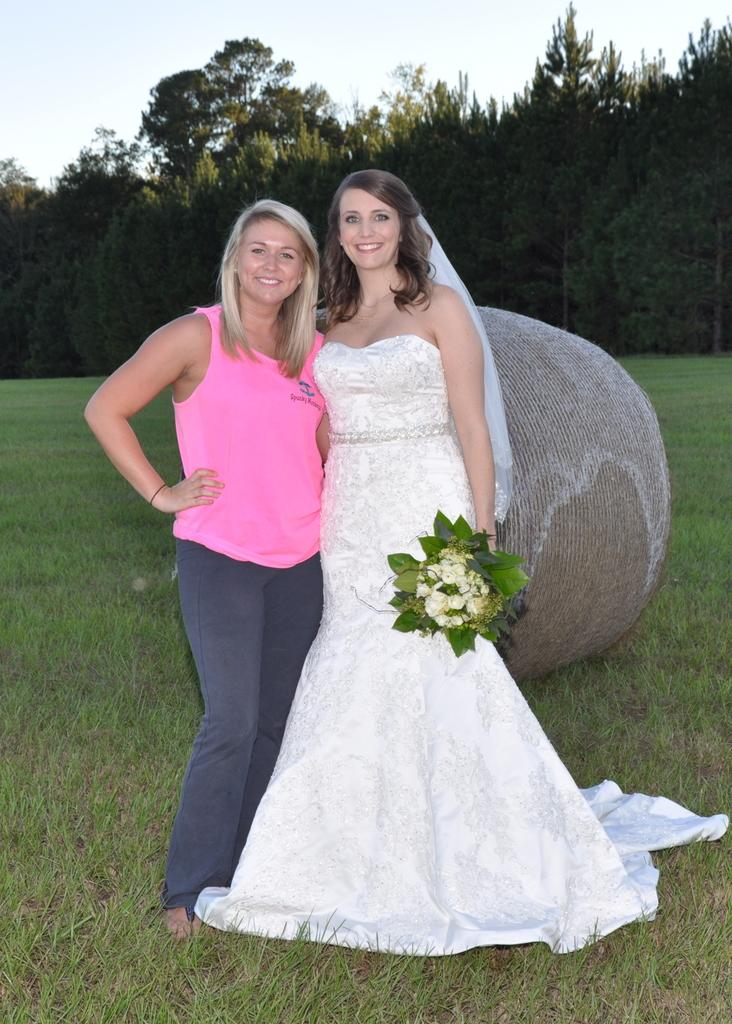What are the women in the image holding? The women are holding bouquets. What can be seen in the background of the image? There is grass, trees, and the sky visible in the background of the image. What learning theory is being applied by the women in the image? There is no indication in the image that the women are applying any learning theory, as they are simply holding bouquets and standing in a natural setting. 